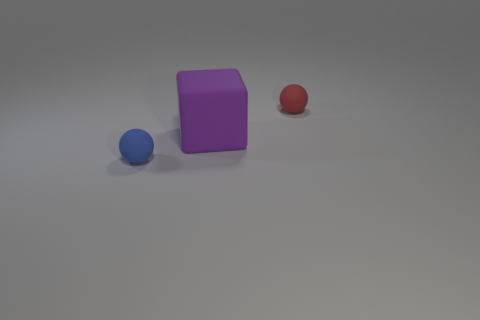Add 3 small matte balls. How many objects exist? 6 Subtract all cubes. How many objects are left? 2 Add 3 tiny red rubber balls. How many tiny red rubber balls exist? 4 Subtract 0 brown spheres. How many objects are left? 3 Subtract all large cyan shiny objects. Subtract all tiny matte balls. How many objects are left? 1 Add 3 large rubber things. How many large rubber things are left? 4 